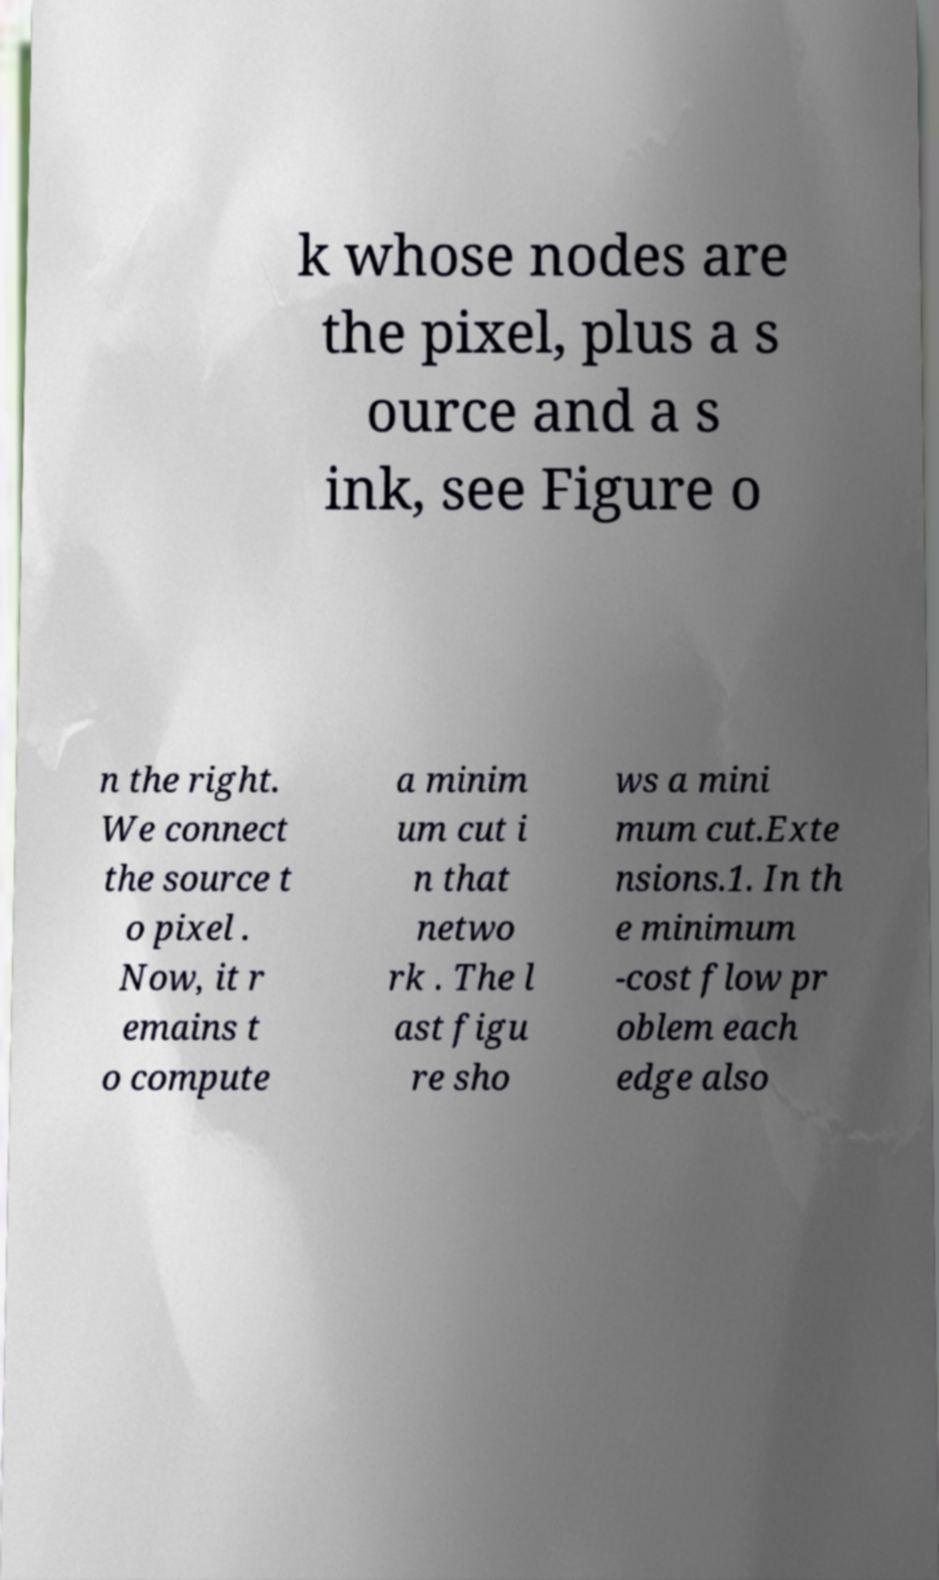Can you read and provide the text displayed in the image?This photo seems to have some interesting text. Can you extract and type it out for me? k whose nodes are the pixel, plus a s ource and a s ink, see Figure o n the right. We connect the source t o pixel . Now, it r emains t o compute a minim um cut i n that netwo rk . The l ast figu re sho ws a mini mum cut.Exte nsions.1. In th e minimum -cost flow pr oblem each edge also 